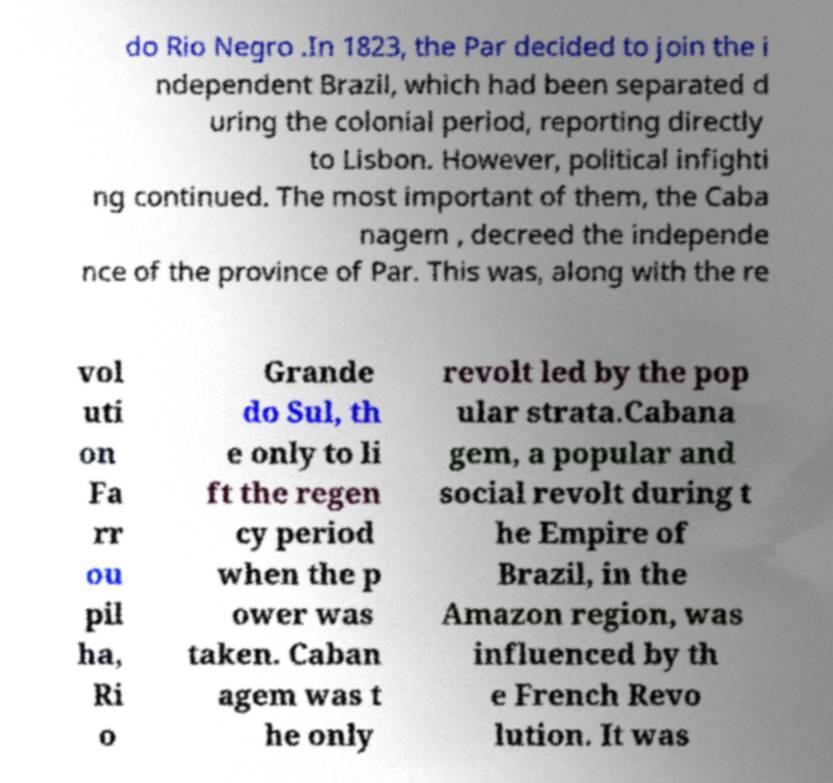Can you accurately transcribe the text from the provided image for me? do Rio Negro .In 1823, the Par decided to join the i ndependent Brazil, which had been separated d uring the colonial period, reporting directly to Lisbon. However, political infighti ng continued. The most important of them, the Caba nagem , decreed the independe nce of the province of Par. This was, along with the re vol uti on Fa rr ou pil ha, Ri o Grande do Sul, th e only to li ft the regen cy period when the p ower was taken. Caban agem was t he only revolt led by the pop ular strata.Cabana gem, a popular and social revolt during t he Empire of Brazil, in the Amazon region, was influenced by th e French Revo lution. It was 